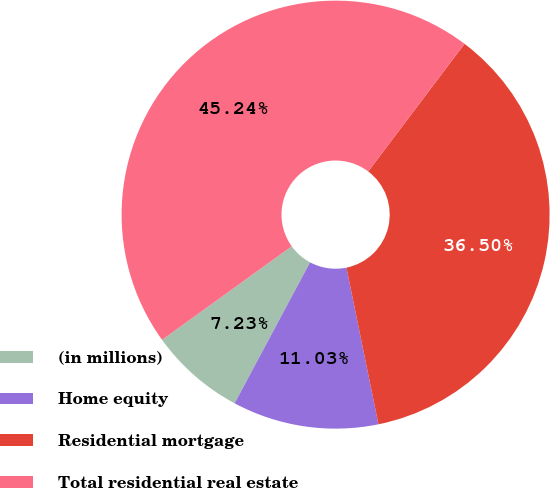Convert chart. <chart><loc_0><loc_0><loc_500><loc_500><pie_chart><fcel>(in millions)<fcel>Home equity<fcel>Residential mortgage<fcel>Total residential real estate<nl><fcel>7.23%<fcel>11.03%<fcel>36.5%<fcel>45.24%<nl></chart> 